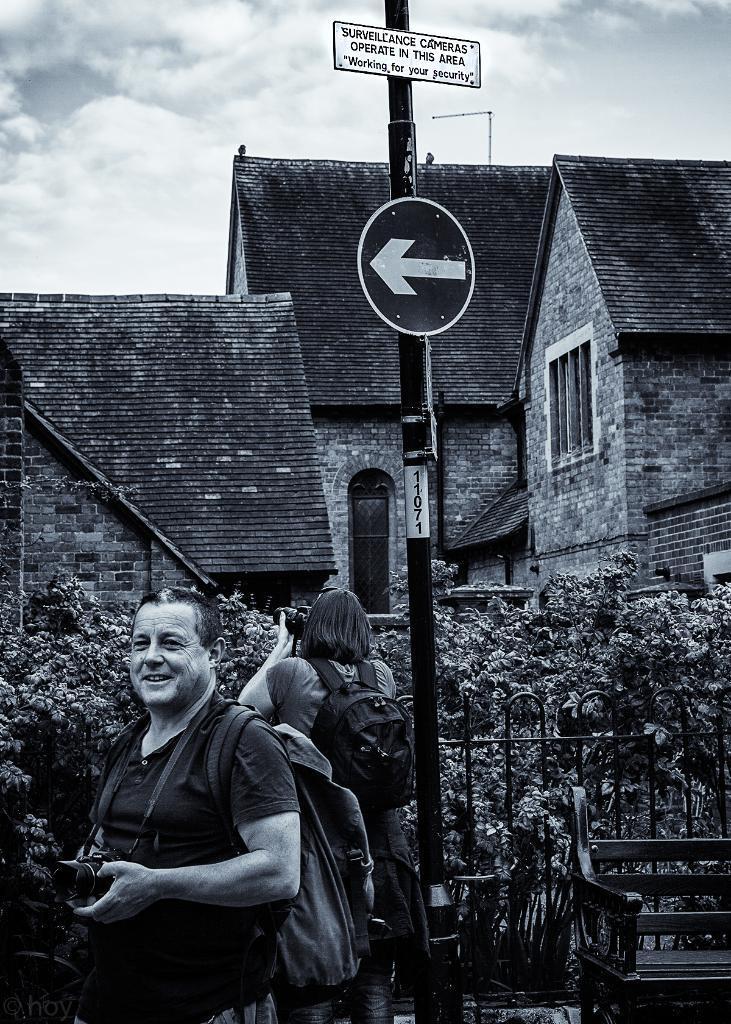Describe this image in one or two sentences. This is a black and white picture. Here we can see houses, pole, boards, fence, bench, plants, and two persons. He is holding a camera and she wore a bag. In the background there is sky with clouds. 